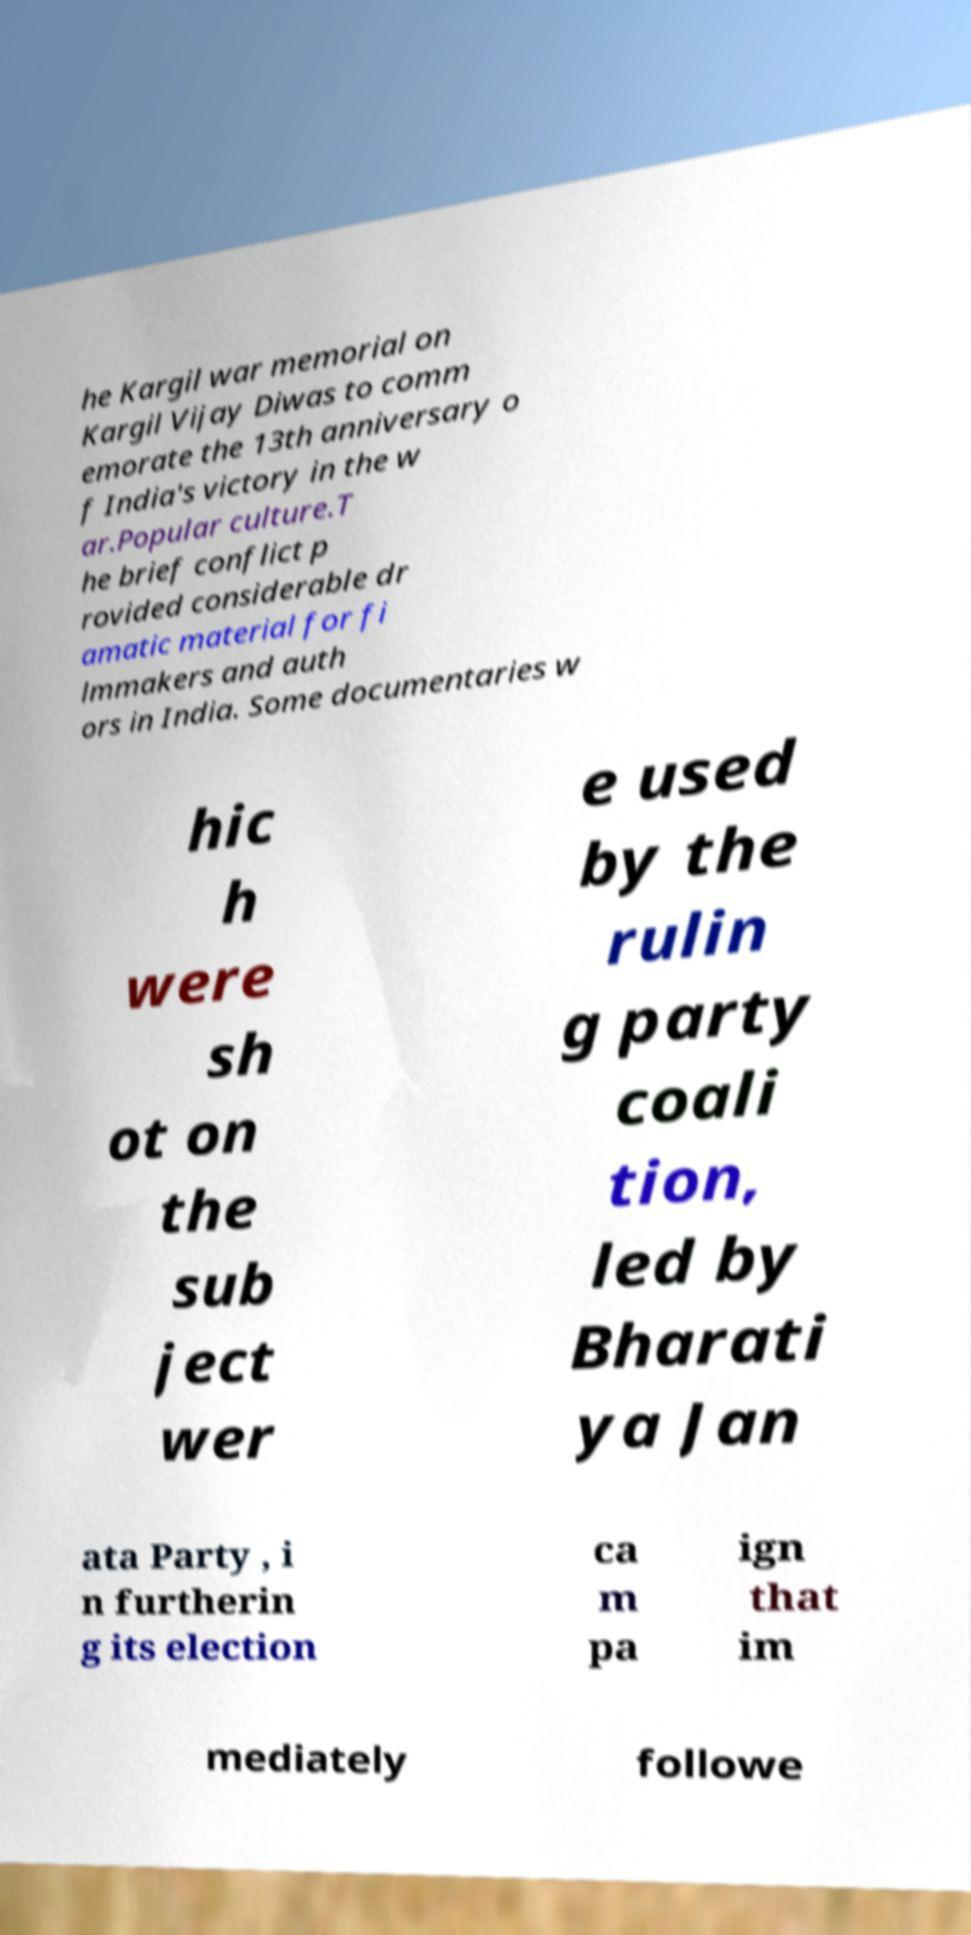Please read and relay the text visible in this image. What does it say? he Kargil war memorial on Kargil Vijay Diwas to comm emorate the 13th anniversary o f India's victory in the w ar.Popular culture.T he brief conflict p rovided considerable dr amatic material for fi lmmakers and auth ors in India. Some documentaries w hic h were sh ot on the sub ject wer e used by the rulin g party coali tion, led by Bharati ya Jan ata Party , i n furtherin g its election ca m pa ign that im mediately followe 